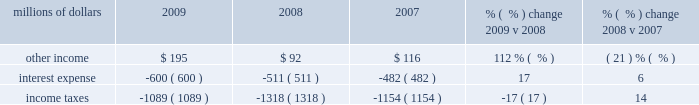An adverse development with respect to one claim in 2008 and favorable developments in three cases in 2009 .
Other costs were also lower in 2009 compared to 2008 , driven by a decrease in expenses for freight and property damages , employee travel , and utilities .
In addition , higher bad debt expense in 2008 due to the uncertain impact of the recessionary economy drove a favorable year-over-year comparison .
Conversely , an additional expense of $ 30 million related to a transaction with pacer international , inc .
And higher property taxes partially offset lower costs in 2009 .
Other costs were higher in 2008 compared to 2007 due to an increase in bad debts , state and local taxes , loss and damage expenses , utility costs , and other miscellaneous expenses totaling $ 122 million .
Conversely , personal injury costs ( including asbestos-related claims ) were $ 8 million lower in 2008 compared to 2007 .
The reduction reflects improvements in our safety experience and lower estimated costs to resolve claims as indicated in the actuarial studies of our personal injury expense and annual reviews of asbestos-related claims in both 2008 and 2007 .
The year-over-year comparison also includes the negative impact of adverse development associated with one claim in 2008 .
In addition , environmental and toxic tort expenses were $ 7 million lower in 2008 compared to 2007 .
Non-operating items millions of dollars 2009 2008 2007 % (  % ) change 2009 v 2008 % (  % ) change 2008 v 2007 .
Other income 2013 other income increased $ 103 million in 2009 compared to 2008 primarily due to higher gains from real estate sales , which included the $ 116 million pre-tax gain from a land sale to the regional transportation district ( rtd ) in colorado and lower interest expense on our sale of receivables program , resulting from lower interest rates and a lower outstanding balance .
Reduced rental and licensing income and lower returns on cash investments , reflecting lower interest rates , partially offset these increases .
Other income decreased in 2008 compared to 2007 due to lower gains from real estate sales and decreased returns on cash investments reflecting lower interest rates .
Higher rental and licensing income and lower interest expense on our sale of receivables program partially offset the decreases .
Interest expense 2013 interest expense increased in 2009 versus 2008 due primarily to higher weighted- average debt levels .
In 2009 , the weighted-average debt level was $ 9.6 billion ( including the restructuring of locomotive leases in may of 2009 ) , compared to $ 8.3 billion in 2008 .
Our effective interest rate was 6.3% ( 6.3 % ) in 2009 , compared to 6.1% ( 6.1 % ) in 2008 .
Interest expense increased in 2008 versus 2007 due to a higher weighted-average debt level of $ 8.3 billion , compared to $ 7.3 billion in 2007 .
A lower effective interest rate of 6.1% ( 6.1 % ) in 2008 , compared to 6.6% ( 6.6 % ) in 2007 , partially offset the effects of the higher weighted-average debt level .
Income taxes 2013 income taxes were lower in 2009 compared to 2008 , driven by lower pre-tax income .
Our effective tax rate for the year was 36.5% ( 36.5 % ) compared to 36.1% ( 36.1 % ) in 2008 .
Income taxes were higher in 2008 compared to 2007 , driven by higher pre-tax income .
Our effective tax rates were 36.1% ( 36.1 % ) and 38.4% ( 38.4 % ) in 2008 and 2007 , respectively .
The lower effective tax rate in 2008 resulted from several reductions in tax expense related to federal audits and state tax law changes .
In addition , the effective tax rate in 2007 was increased by illinois legislation that increased deferred tax expense in the third quarter of 2007. .
What would other income have increased to in 2009 absent the pre-tax gain from a land sale , in millions? 
Computations: (195 - 116)
Answer: 79.0. 